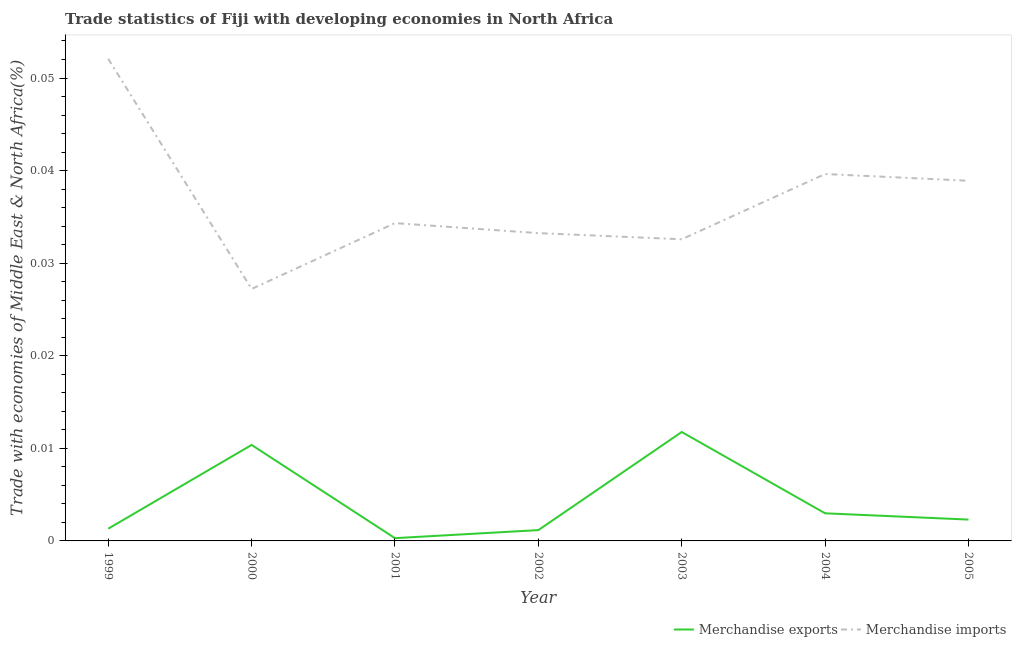What is the merchandise exports in 2004?
Your response must be concise. 0. Across all years, what is the maximum merchandise imports?
Give a very brief answer. 0.05. Across all years, what is the minimum merchandise exports?
Your answer should be very brief. 0. In which year was the merchandise imports maximum?
Your answer should be compact. 1999. In which year was the merchandise imports minimum?
Make the answer very short. 2000. What is the total merchandise imports in the graph?
Offer a terse response. 0.26. What is the difference between the merchandise exports in 2000 and that in 2005?
Your answer should be very brief. 0.01. What is the difference between the merchandise imports in 2005 and the merchandise exports in 2001?
Provide a short and direct response. 0.04. What is the average merchandise imports per year?
Your answer should be compact. 0.04. In the year 2001, what is the difference between the merchandise exports and merchandise imports?
Your response must be concise. -0.03. What is the ratio of the merchandise imports in 2001 to that in 2004?
Your answer should be compact. 0.87. Is the merchandise imports in 2000 less than that in 2001?
Ensure brevity in your answer.  Yes. What is the difference between the highest and the second highest merchandise exports?
Give a very brief answer. 0. What is the difference between the highest and the lowest merchandise exports?
Keep it short and to the point. 0.01. Is the sum of the merchandise imports in 2002 and 2005 greater than the maximum merchandise exports across all years?
Offer a terse response. Yes. Does the merchandise imports monotonically increase over the years?
Provide a succinct answer. No. Is the merchandise imports strictly greater than the merchandise exports over the years?
Provide a succinct answer. Yes. How many lines are there?
Give a very brief answer. 2. Are the values on the major ticks of Y-axis written in scientific E-notation?
Provide a short and direct response. No. Does the graph contain grids?
Provide a short and direct response. No. How many legend labels are there?
Make the answer very short. 2. How are the legend labels stacked?
Ensure brevity in your answer.  Horizontal. What is the title of the graph?
Your answer should be very brief. Trade statistics of Fiji with developing economies in North Africa. Does "Non-residents" appear as one of the legend labels in the graph?
Ensure brevity in your answer.  No. What is the label or title of the Y-axis?
Provide a succinct answer. Trade with economies of Middle East & North Africa(%). What is the Trade with economies of Middle East & North Africa(%) in Merchandise exports in 1999?
Provide a short and direct response. 0. What is the Trade with economies of Middle East & North Africa(%) in Merchandise imports in 1999?
Make the answer very short. 0.05. What is the Trade with economies of Middle East & North Africa(%) in Merchandise exports in 2000?
Offer a terse response. 0.01. What is the Trade with economies of Middle East & North Africa(%) in Merchandise imports in 2000?
Offer a very short reply. 0.03. What is the Trade with economies of Middle East & North Africa(%) of Merchandise exports in 2001?
Provide a succinct answer. 0. What is the Trade with economies of Middle East & North Africa(%) of Merchandise imports in 2001?
Give a very brief answer. 0.03. What is the Trade with economies of Middle East & North Africa(%) in Merchandise exports in 2002?
Give a very brief answer. 0. What is the Trade with economies of Middle East & North Africa(%) in Merchandise imports in 2002?
Offer a terse response. 0.03. What is the Trade with economies of Middle East & North Africa(%) of Merchandise exports in 2003?
Your answer should be very brief. 0.01. What is the Trade with economies of Middle East & North Africa(%) in Merchandise imports in 2003?
Provide a short and direct response. 0.03. What is the Trade with economies of Middle East & North Africa(%) in Merchandise exports in 2004?
Ensure brevity in your answer.  0. What is the Trade with economies of Middle East & North Africa(%) of Merchandise imports in 2004?
Offer a very short reply. 0.04. What is the Trade with economies of Middle East & North Africa(%) of Merchandise exports in 2005?
Your response must be concise. 0. What is the Trade with economies of Middle East & North Africa(%) in Merchandise imports in 2005?
Your answer should be compact. 0.04. Across all years, what is the maximum Trade with economies of Middle East & North Africa(%) of Merchandise exports?
Provide a succinct answer. 0.01. Across all years, what is the maximum Trade with economies of Middle East & North Africa(%) in Merchandise imports?
Provide a succinct answer. 0.05. Across all years, what is the minimum Trade with economies of Middle East & North Africa(%) of Merchandise exports?
Provide a short and direct response. 0. Across all years, what is the minimum Trade with economies of Middle East & North Africa(%) of Merchandise imports?
Make the answer very short. 0.03. What is the total Trade with economies of Middle East & North Africa(%) of Merchandise exports in the graph?
Provide a short and direct response. 0.03. What is the total Trade with economies of Middle East & North Africa(%) of Merchandise imports in the graph?
Provide a succinct answer. 0.26. What is the difference between the Trade with economies of Middle East & North Africa(%) in Merchandise exports in 1999 and that in 2000?
Offer a very short reply. -0.01. What is the difference between the Trade with economies of Middle East & North Africa(%) of Merchandise imports in 1999 and that in 2000?
Offer a very short reply. 0.02. What is the difference between the Trade with economies of Middle East & North Africa(%) in Merchandise imports in 1999 and that in 2001?
Offer a very short reply. 0.02. What is the difference between the Trade with economies of Middle East & North Africa(%) of Merchandise exports in 1999 and that in 2002?
Your answer should be compact. 0. What is the difference between the Trade with economies of Middle East & North Africa(%) of Merchandise imports in 1999 and that in 2002?
Offer a terse response. 0.02. What is the difference between the Trade with economies of Middle East & North Africa(%) in Merchandise exports in 1999 and that in 2003?
Keep it short and to the point. -0.01. What is the difference between the Trade with economies of Middle East & North Africa(%) in Merchandise imports in 1999 and that in 2003?
Ensure brevity in your answer.  0.02. What is the difference between the Trade with economies of Middle East & North Africa(%) in Merchandise exports in 1999 and that in 2004?
Give a very brief answer. -0. What is the difference between the Trade with economies of Middle East & North Africa(%) of Merchandise imports in 1999 and that in 2004?
Provide a succinct answer. 0.01. What is the difference between the Trade with economies of Middle East & North Africa(%) of Merchandise exports in 1999 and that in 2005?
Make the answer very short. -0. What is the difference between the Trade with economies of Middle East & North Africa(%) in Merchandise imports in 1999 and that in 2005?
Your answer should be compact. 0.01. What is the difference between the Trade with economies of Middle East & North Africa(%) in Merchandise exports in 2000 and that in 2001?
Keep it short and to the point. 0.01. What is the difference between the Trade with economies of Middle East & North Africa(%) in Merchandise imports in 2000 and that in 2001?
Provide a short and direct response. -0.01. What is the difference between the Trade with economies of Middle East & North Africa(%) in Merchandise exports in 2000 and that in 2002?
Keep it short and to the point. 0.01. What is the difference between the Trade with economies of Middle East & North Africa(%) of Merchandise imports in 2000 and that in 2002?
Ensure brevity in your answer.  -0.01. What is the difference between the Trade with economies of Middle East & North Africa(%) of Merchandise exports in 2000 and that in 2003?
Ensure brevity in your answer.  -0. What is the difference between the Trade with economies of Middle East & North Africa(%) in Merchandise imports in 2000 and that in 2003?
Offer a terse response. -0.01. What is the difference between the Trade with economies of Middle East & North Africa(%) of Merchandise exports in 2000 and that in 2004?
Offer a terse response. 0.01. What is the difference between the Trade with economies of Middle East & North Africa(%) in Merchandise imports in 2000 and that in 2004?
Offer a terse response. -0.01. What is the difference between the Trade with economies of Middle East & North Africa(%) in Merchandise exports in 2000 and that in 2005?
Ensure brevity in your answer.  0.01. What is the difference between the Trade with economies of Middle East & North Africa(%) in Merchandise imports in 2000 and that in 2005?
Give a very brief answer. -0.01. What is the difference between the Trade with economies of Middle East & North Africa(%) of Merchandise exports in 2001 and that in 2002?
Your answer should be compact. -0. What is the difference between the Trade with economies of Middle East & North Africa(%) in Merchandise imports in 2001 and that in 2002?
Make the answer very short. 0. What is the difference between the Trade with economies of Middle East & North Africa(%) of Merchandise exports in 2001 and that in 2003?
Your answer should be compact. -0.01. What is the difference between the Trade with economies of Middle East & North Africa(%) in Merchandise imports in 2001 and that in 2003?
Keep it short and to the point. 0. What is the difference between the Trade with economies of Middle East & North Africa(%) of Merchandise exports in 2001 and that in 2004?
Keep it short and to the point. -0. What is the difference between the Trade with economies of Middle East & North Africa(%) in Merchandise imports in 2001 and that in 2004?
Ensure brevity in your answer.  -0.01. What is the difference between the Trade with economies of Middle East & North Africa(%) of Merchandise exports in 2001 and that in 2005?
Provide a succinct answer. -0. What is the difference between the Trade with economies of Middle East & North Africa(%) in Merchandise imports in 2001 and that in 2005?
Keep it short and to the point. -0. What is the difference between the Trade with economies of Middle East & North Africa(%) of Merchandise exports in 2002 and that in 2003?
Keep it short and to the point. -0.01. What is the difference between the Trade with economies of Middle East & North Africa(%) in Merchandise imports in 2002 and that in 2003?
Keep it short and to the point. 0. What is the difference between the Trade with economies of Middle East & North Africa(%) of Merchandise exports in 2002 and that in 2004?
Ensure brevity in your answer.  -0. What is the difference between the Trade with economies of Middle East & North Africa(%) of Merchandise imports in 2002 and that in 2004?
Give a very brief answer. -0.01. What is the difference between the Trade with economies of Middle East & North Africa(%) of Merchandise exports in 2002 and that in 2005?
Provide a succinct answer. -0. What is the difference between the Trade with economies of Middle East & North Africa(%) in Merchandise imports in 2002 and that in 2005?
Provide a short and direct response. -0.01. What is the difference between the Trade with economies of Middle East & North Africa(%) in Merchandise exports in 2003 and that in 2004?
Offer a very short reply. 0.01. What is the difference between the Trade with economies of Middle East & North Africa(%) in Merchandise imports in 2003 and that in 2004?
Make the answer very short. -0.01. What is the difference between the Trade with economies of Middle East & North Africa(%) in Merchandise exports in 2003 and that in 2005?
Keep it short and to the point. 0.01. What is the difference between the Trade with economies of Middle East & North Africa(%) in Merchandise imports in 2003 and that in 2005?
Your answer should be very brief. -0.01. What is the difference between the Trade with economies of Middle East & North Africa(%) in Merchandise exports in 2004 and that in 2005?
Make the answer very short. 0. What is the difference between the Trade with economies of Middle East & North Africa(%) in Merchandise imports in 2004 and that in 2005?
Your answer should be very brief. 0. What is the difference between the Trade with economies of Middle East & North Africa(%) in Merchandise exports in 1999 and the Trade with economies of Middle East & North Africa(%) in Merchandise imports in 2000?
Keep it short and to the point. -0.03. What is the difference between the Trade with economies of Middle East & North Africa(%) of Merchandise exports in 1999 and the Trade with economies of Middle East & North Africa(%) of Merchandise imports in 2001?
Give a very brief answer. -0.03. What is the difference between the Trade with economies of Middle East & North Africa(%) of Merchandise exports in 1999 and the Trade with economies of Middle East & North Africa(%) of Merchandise imports in 2002?
Give a very brief answer. -0.03. What is the difference between the Trade with economies of Middle East & North Africa(%) in Merchandise exports in 1999 and the Trade with economies of Middle East & North Africa(%) in Merchandise imports in 2003?
Provide a succinct answer. -0.03. What is the difference between the Trade with economies of Middle East & North Africa(%) of Merchandise exports in 1999 and the Trade with economies of Middle East & North Africa(%) of Merchandise imports in 2004?
Your response must be concise. -0.04. What is the difference between the Trade with economies of Middle East & North Africa(%) in Merchandise exports in 1999 and the Trade with economies of Middle East & North Africa(%) in Merchandise imports in 2005?
Ensure brevity in your answer.  -0.04. What is the difference between the Trade with economies of Middle East & North Africa(%) of Merchandise exports in 2000 and the Trade with economies of Middle East & North Africa(%) of Merchandise imports in 2001?
Provide a short and direct response. -0.02. What is the difference between the Trade with economies of Middle East & North Africa(%) in Merchandise exports in 2000 and the Trade with economies of Middle East & North Africa(%) in Merchandise imports in 2002?
Ensure brevity in your answer.  -0.02. What is the difference between the Trade with economies of Middle East & North Africa(%) in Merchandise exports in 2000 and the Trade with economies of Middle East & North Africa(%) in Merchandise imports in 2003?
Your answer should be compact. -0.02. What is the difference between the Trade with economies of Middle East & North Africa(%) in Merchandise exports in 2000 and the Trade with economies of Middle East & North Africa(%) in Merchandise imports in 2004?
Make the answer very short. -0.03. What is the difference between the Trade with economies of Middle East & North Africa(%) in Merchandise exports in 2000 and the Trade with economies of Middle East & North Africa(%) in Merchandise imports in 2005?
Ensure brevity in your answer.  -0.03. What is the difference between the Trade with economies of Middle East & North Africa(%) of Merchandise exports in 2001 and the Trade with economies of Middle East & North Africa(%) of Merchandise imports in 2002?
Keep it short and to the point. -0.03. What is the difference between the Trade with economies of Middle East & North Africa(%) in Merchandise exports in 2001 and the Trade with economies of Middle East & North Africa(%) in Merchandise imports in 2003?
Make the answer very short. -0.03. What is the difference between the Trade with economies of Middle East & North Africa(%) of Merchandise exports in 2001 and the Trade with economies of Middle East & North Africa(%) of Merchandise imports in 2004?
Ensure brevity in your answer.  -0.04. What is the difference between the Trade with economies of Middle East & North Africa(%) in Merchandise exports in 2001 and the Trade with economies of Middle East & North Africa(%) in Merchandise imports in 2005?
Ensure brevity in your answer.  -0.04. What is the difference between the Trade with economies of Middle East & North Africa(%) of Merchandise exports in 2002 and the Trade with economies of Middle East & North Africa(%) of Merchandise imports in 2003?
Offer a terse response. -0.03. What is the difference between the Trade with economies of Middle East & North Africa(%) in Merchandise exports in 2002 and the Trade with economies of Middle East & North Africa(%) in Merchandise imports in 2004?
Give a very brief answer. -0.04. What is the difference between the Trade with economies of Middle East & North Africa(%) in Merchandise exports in 2002 and the Trade with economies of Middle East & North Africa(%) in Merchandise imports in 2005?
Make the answer very short. -0.04. What is the difference between the Trade with economies of Middle East & North Africa(%) in Merchandise exports in 2003 and the Trade with economies of Middle East & North Africa(%) in Merchandise imports in 2004?
Provide a succinct answer. -0.03. What is the difference between the Trade with economies of Middle East & North Africa(%) of Merchandise exports in 2003 and the Trade with economies of Middle East & North Africa(%) of Merchandise imports in 2005?
Offer a very short reply. -0.03. What is the difference between the Trade with economies of Middle East & North Africa(%) in Merchandise exports in 2004 and the Trade with economies of Middle East & North Africa(%) in Merchandise imports in 2005?
Give a very brief answer. -0.04. What is the average Trade with economies of Middle East & North Africa(%) in Merchandise exports per year?
Keep it short and to the point. 0. What is the average Trade with economies of Middle East & North Africa(%) in Merchandise imports per year?
Make the answer very short. 0.04. In the year 1999, what is the difference between the Trade with economies of Middle East & North Africa(%) of Merchandise exports and Trade with economies of Middle East & North Africa(%) of Merchandise imports?
Your answer should be compact. -0.05. In the year 2000, what is the difference between the Trade with economies of Middle East & North Africa(%) in Merchandise exports and Trade with economies of Middle East & North Africa(%) in Merchandise imports?
Ensure brevity in your answer.  -0.02. In the year 2001, what is the difference between the Trade with economies of Middle East & North Africa(%) of Merchandise exports and Trade with economies of Middle East & North Africa(%) of Merchandise imports?
Provide a short and direct response. -0.03. In the year 2002, what is the difference between the Trade with economies of Middle East & North Africa(%) of Merchandise exports and Trade with economies of Middle East & North Africa(%) of Merchandise imports?
Make the answer very short. -0.03. In the year 2003, what is the difference between the Trade with economies of Middle East & North Africa(%) of Merchandise exports and Trade with economies of Middle East & North Africa(%) of Merchandise imports?
Provide a succinct answer. -0.02. In the year 2004, what is the difference between the Trade with economies of Middle East & North Africa(%) in Merchandise exports and Trade with economies of Middle East & North Africa(%) in Merchandise imports?
Provide a short and direct response. -0.04. In the year 2005, what is the difference between the Trade with economies of Middle East & North Africa(%) of Merchandise exports and Trade with economies of Middle East & North Africa(%) of Merchandise imports?
Make the answer very short. -0.04. What is the ratio of the Trade with economies of Middle East & North Africa(%) of Merchandise exports in 1999 to that in 2000?
Provide a short and direct response. 0.13. What is the ratio of the Trade with economies of Middle East & North Africa(%) of Merchandise imports in 1999 to that in 2000?
Offer a very short reply. 1.91. What is the ratio of the Trade with economies of Middle East & North Africa(%) in Merchandise exports in 1999 to that in 2001?
Your response must be concise. 4.43. What is the ratio of the Trade with economies of Middle East & North Africa(%) in Merchandise imports in 1999 to that in 2001?
Ensure brevity in your answer.  1.52. What is the ratio of the Trade with economies of Middle East & North Africa(%) in Merchandise exports in 1999 to that in 2002?
Your answer should be very brief. 1.13. What is the ratio of the Trade with economies of Middle East & North Africa(%) of Merchandise imports in 1999 to that in 2002?
Provide a short and direct response. 1.57. What is the ratio of the Trade with economies of Middle East & North Africa(%) in Merchandise exports in 1999 to that in 2003?
Make the answer very short. 0.11. What is the ratio of the Trade with economies of Middle East & North Africa(%) of Merchandise imports in 1999 to that in 2003?
Provide a short and direct response. 1.6. What is the ratio of the Trade with economies of Middle East & North Africa(%) of Merchandise exports in 1999 to that in 2004?
Your answer should be very brief. 0.44. What is the ratio of the Trade with economies of Middle East & North Africa(%) of Merchandise imports in 1999 to that in 2004?
Your answer should be very brief. 1.31. What is the ratio of the Trade with economies of Middle East & North Africa(%) in Merchandise exports in 1999 to that in 2005?
Offer a terse response. 0.57. What is the ratio of the Trade with economies of Middle East & North Africa(%) in Merchandise imports in 1999 to that in 2005?
Provide a succinct answer. 1.34. What is the ratio of the Trade with economies of Middle East & North Africa(%) in Merchandise exports in 2000 to that in 2001?
Provide a succinct answer. 34.76. What is the ratio of the Trade with economies of Middle East & North Africa(%) of Merchandise imports in 2000 to that in 2001?
Make the answer very short. 0.79. What is the ratio of the Trade with economies of Middle East & North Africa(%) of Merchandise exports in 2000 to that in 2002?
Make the answer very short. 8.88. What is the ratio of the Trade with economies of Middle East & North Africa(%) of Merchandise imports in 2000 to that in 2002?
Give a very brief answer. 0.82. What is the ratio of the Trade with economies of Middle East & North Africa(%) in Merchandise exports in 2000 to that in 2003?
Make the answer very short. 0.88. What is the ratio of the Trade with economies of Middle East & North Africa(%) in Merchandise imports in 2000 to that in 2003?
Give a very brief answer. 0.84. What is the ratio of the Trade with economies of Middle East & North Africa(%) of Merchandise exports in 2000 to that in 2004?
Keep it short and to the point. 3.48. What is the ratio of the Trade with economies of Middle East & North Africa(%) in Merchandise imports in 2000 to that in 2004?
Offer a very short reply. 0.69. What is the ratio of the Trade with economies of Middle East & North Africa(%) in Merchandise exports in 2000 to that in 2005?
Your answer should be very brief. 4.5. What is the ratio of the Trade with economies of Middle East & North Africa(%) of Merchandise imports in 2000 to that in 2005?
Your answer should be very brief. 0.7. What is the ratio of the Trade with economies of Middle East & North Africa(%) in Merchandise exports in 2001 to that in 2002?
Your answer should be compact. 0.26. What is the ratio of the Trade with economies of Middle East & North Africa(%) of Merchandise imports in 2001 to that in 2002?
Give a very brief answer. 1.03. What is the ratio of the Trade with economies of Middle East & North Africa(%) in Merchandise exports in 2001 to that in 2003?
Your answer should be very brief. 0.03. What is the ratio of the Trade with economies of Middle East & North Africa(%) in Merchandise imports in 2001 to that in 2003?
Offer a very short reply. 1.05. What is the ratio of the Trade with economies of Middle East & North Africa(%) of Merchandise exports in 2001 to that in 2004?
Your answer should be very brief. 0.1. What is the ratio of the Trade with economies of Middle East & North Africa(%) in Merchandise imports in 2001 to that in 2004?
Ensure brevity in your answer.  0.87. What is the ratio of the Trade with economies of Middle East & North Africa(%) of Merchandise exports in 2001 to that in 2005?
Your response must be concise. 0.13. What is the ratio of the Trade with economies of Middle East & North Africa(%) in Merchandise imports in 2001 to that in 2005?
Give a very brief answer. 0.88. What is the ratio of the Trade with economies of Middle East & North Africa(%) in Merchandise exports in 2002 to that in 2003?
Ensure brevity in your answer.  0.1. What is the ratio of the Trade with economies of Middle East & North Africa(%) of Merchandise imports in 2002 to that in 2003?
Provide a short and direct response. 1.02. What is the ratio of the Trade with economies of Middle East & North Africa(%) of Merchandise exports in 2002 to that in 2004?
Ensure brevity in your answer.  0.39. What is the ratio of the Trade with economies of Middle East & North Africa(%) of Merchandise imports in 2002 to that in 2004?
Make the answer very short. 0.84. What is the ratio of the Trade with economies of Middle East & North Africa(%) in Merchandise exports in 2002 to that in 2005?
Ensure brevity in your answer.  0.51. What is the ratio of the Trade with economies of Middle East & North Africa(%) in Merchandise imports in 2002 to that in 2005?
Your response must be concise. 0.85. What is the ratio of the Trade with economies of Middle East & North Africa(%) of Merchandise exports in 2003 to that in 2004?
Keep it short and to the point. 3.94. What is the ratio of the Trade with economies of Middle East & North Africa(%) in Merchandise imports in 2003 to that in 2004?
Provide a short and direct response. 0.82. What is the ratio of the Trade with economies of Middle East & North Africa(%) of Merchandise exports in 2003 to that in 2005?
Offer a terse response. 5.1. What is the ratio of the Trade with economies of Middle East & North Africa(%) in Merchandise imports in 2003 to that in 2005?
Provide a short and direct response. 0.84. What is the ratio of the Trade with economies of Middle East & North Africa(%) of Merchandise exports in 2004 to that in 2005?
Offer a terse response. 1.29. What is the ratio of the Trade with economies of Middle East & North Africa(%) of Merchandise imports in 2004 to that in 2005?
Your response must be concise. 1.02. What is the difference between the highest and the second highest Trade with economies of Middle East & North Africa(%) in Merchandise exports?
Ensure brevity in your answer.  0. What is the difference between the highest and the second highest Trade with economies of Middle East & North Africa(%) in Merchandise imports?
Offer a very short reply. 0.01. What is the difference between the highest and the lowest Trade with economies of Middle East & North Africa(%) of Merchandise exports?
Provide a short and direct response. 0.01. What is the difference between the highest and the lowest Trade with economies of Middle East & North Africa(%) of Merchandise imports?
Your answer should be very brief. 0.02. 